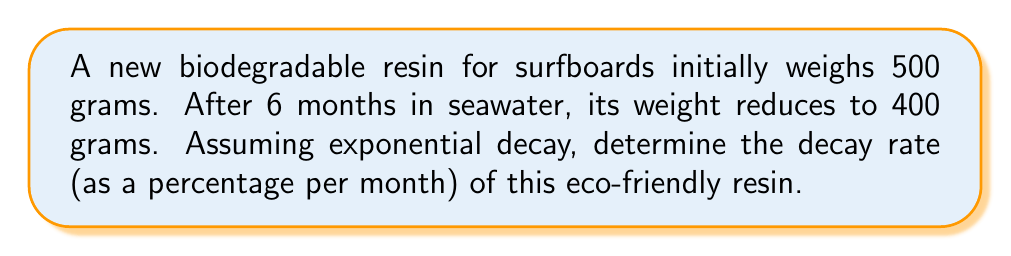Teach me how to tackle this problem. To solve this problem, we'll use the exponential decay formula:

$A(t) = A_0 e^{-rt}$

Where:
$A(t)$ is the amount at time $t$
$A_0$ is the initial amount
$r$ is the decay rate
$t$ is the time

1) We know:
   $A_0 = 500$ grams
   $A(6) = 400$ grams
   $t = 6$ months

2) Plug these values into the formula:
   $400 = 500 e^{-6r}$

3) Divide both sides by 500:
   $\frac{400}{500} = e^{-6r}$
   $0.8 = e^{-6r}$

4) Take the natural log of both sides:
   $\ln(0.8) = \ln(e^{-6r})$
   $\ln(0.8) = -6r$

5) Solve for $r$:
   $r = -\frac{\ln(0.8)}{6}$
   $r \approx 0.0372$ per month

6) Convert to a percentage:
   $0.0372 \times 100\% \approx 3.72\%$ per month

Therefore, the decay rate of the biodegradable resin is approximately 3.72% per month.
Answer: 3.72% per month 